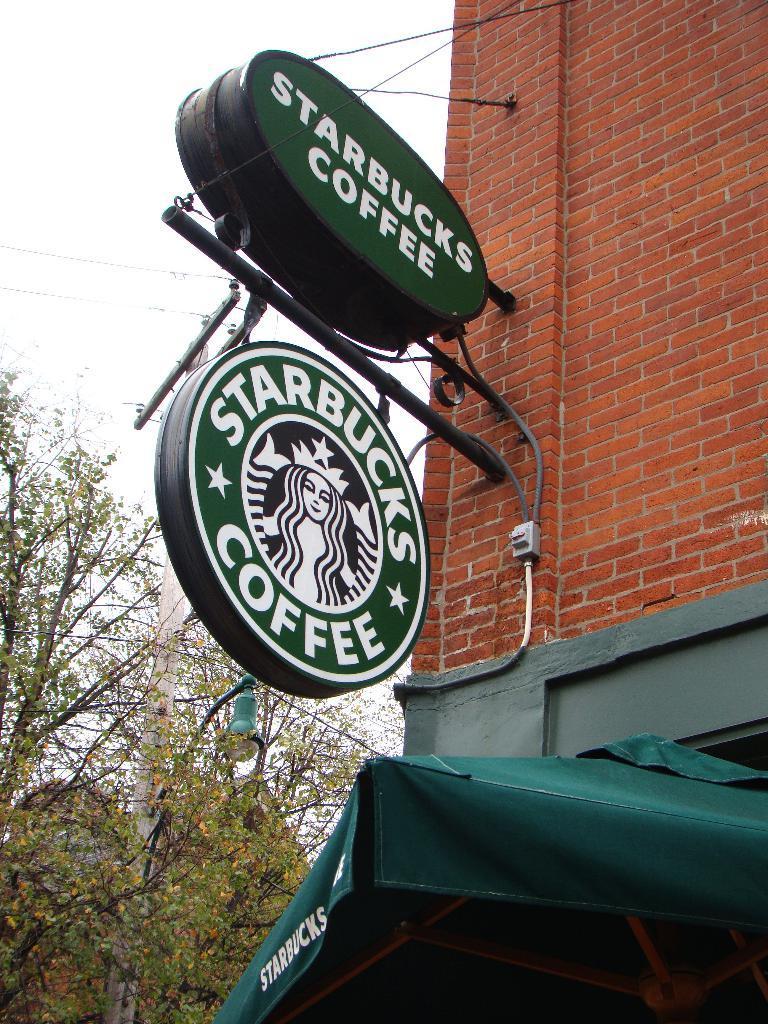In one or two sentences, can you explain what this image depicts? In the center of the image there are advertisement boards. In the background of the image there are trees. There is a building. 